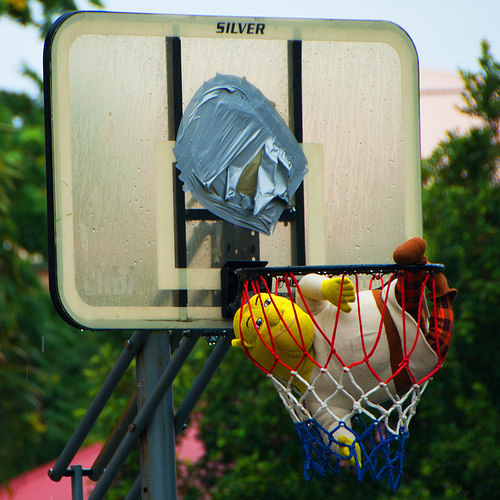<image>
Can you confirm if the stuffed animal is in the basketball net? Yes. The stuffed animal is contained within or inside the basketball net, showing a containment relationship. 